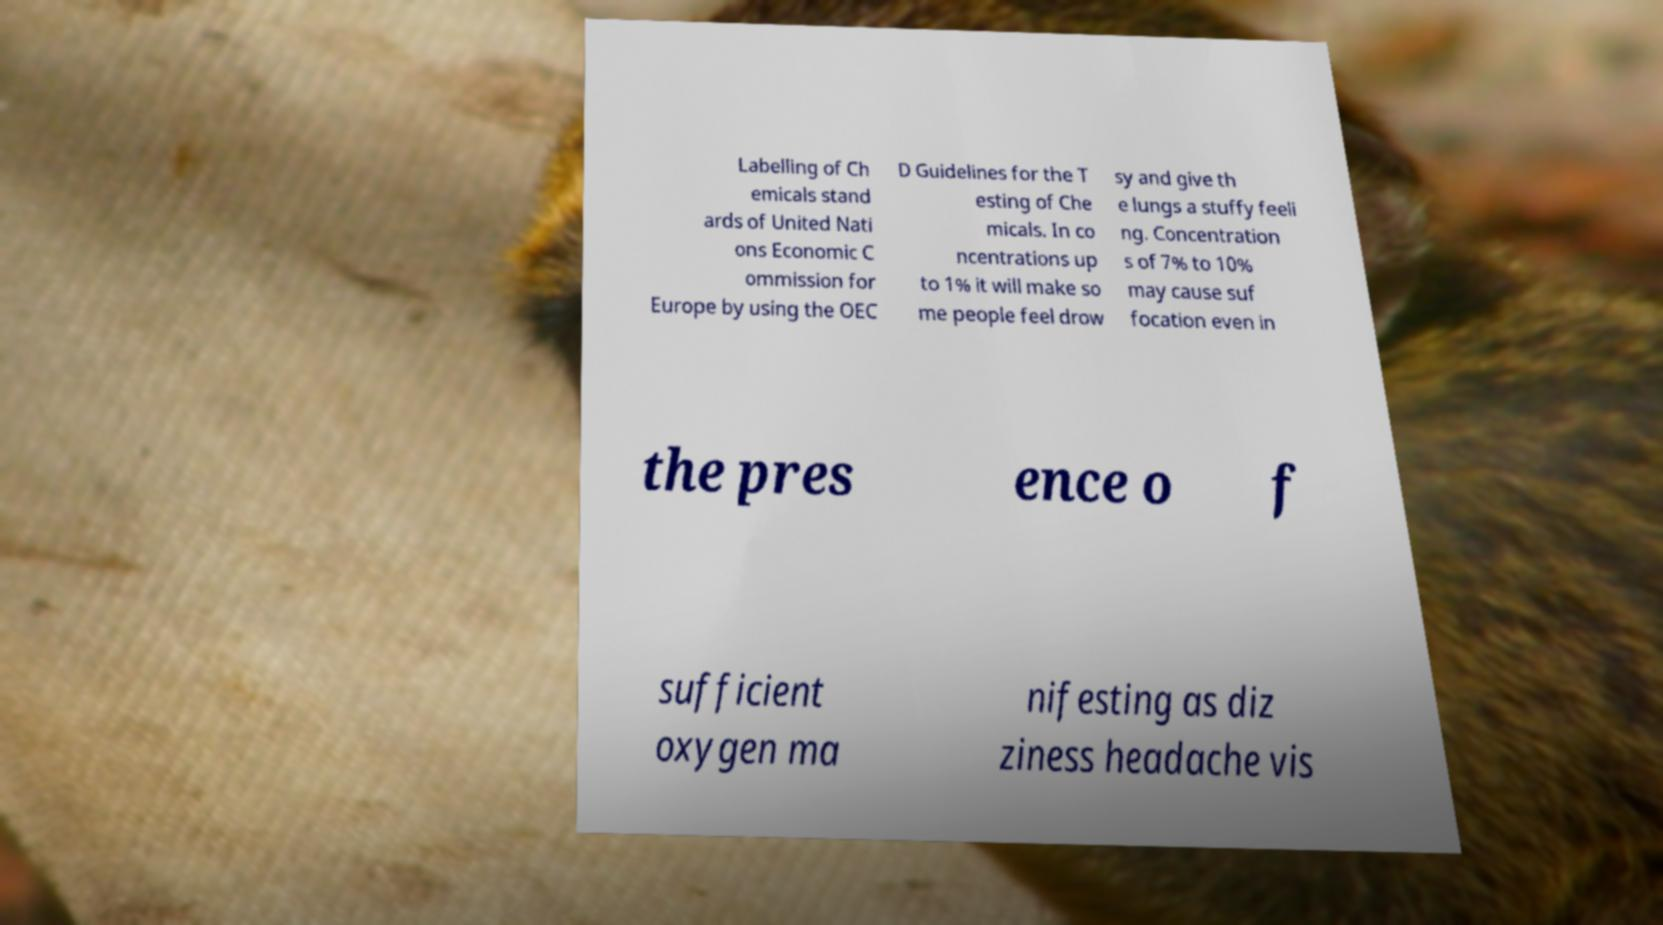There's text embedded in this image that I need extracted. Can you transcribe it verbatim? Labelling of Ch emicals stand ards of United Nati ons Economic C ommission for Europe by using the OEC D Guidelines for the T esting of Che micals. In co ncentrations up to 1% it will make so me people feel drow sy and give th e lungs a stuffy feeli ng. Concentration s of 7% to 10% may cause suf focation even in the pres ence o f sufficient oxygen ma nifesting as diz ziness headache vis 